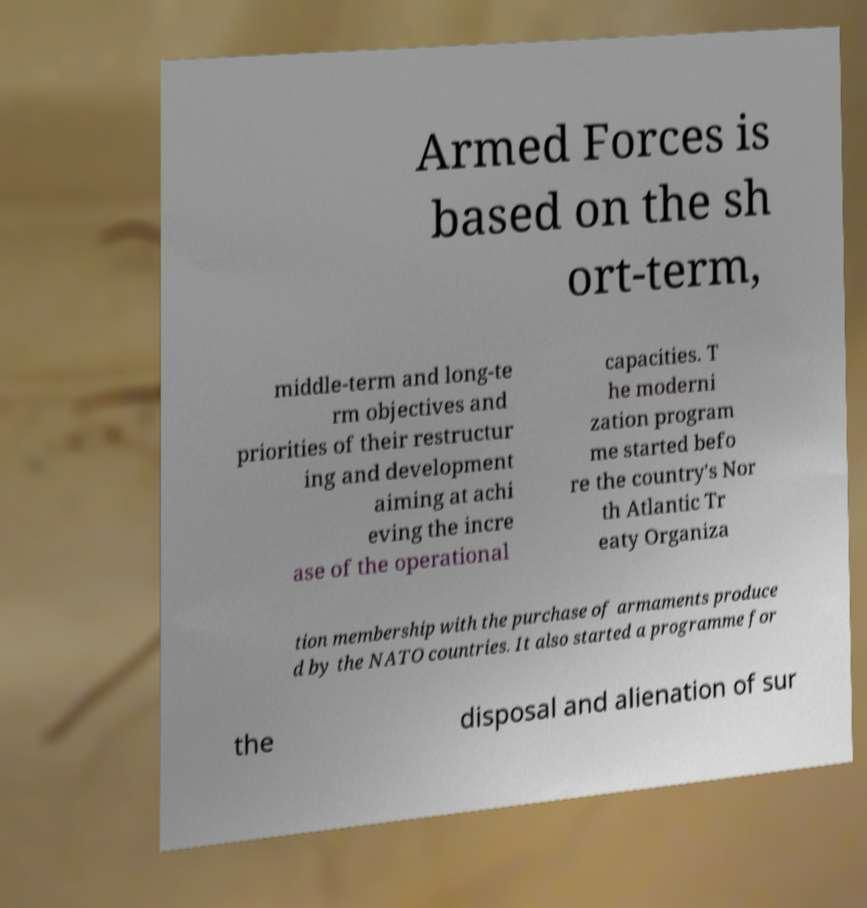Can you read and provide the text displayed in the image?This photo seems to have some interesting text. Can you extract and type it out for me? Armed Forces is based on the sh ort-term, middle-term and long-te rm objectives and priorities of their restructur ing and development aiming at achi eving the incre ase of the operational capacities. T he moderni zation program me started befo re the country's Nor th Atlantic Tr eaty Organiza tion membership with the purchase of armaments produce d by the NATO countries. It also started a programme for the disposal and alienation of sur 